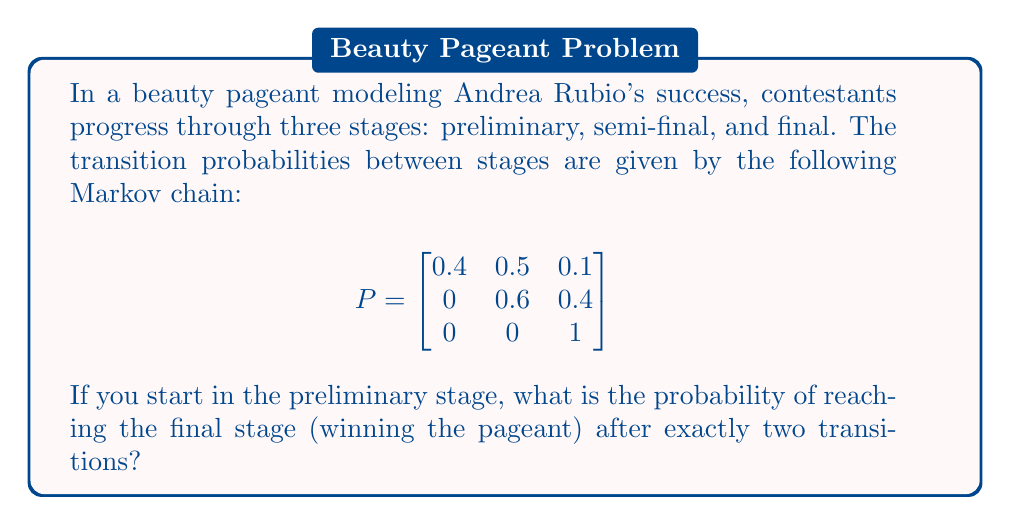Show me your answer to this math problem. To solve this problem, we'll use the Markov chain model and calculate the probability of reaching the final stage in exactly two steps:

1. First, we need to understand what the matrix P represents:
   - $P_{ij}$ is the probability of moving from state i to state j in one step
   - States: 1 = Preliminary, 2 = Semi-final, 3 = Final

2. To reach the final stage in exactly two transitions, we need to:
   - Move from Preliminary to Semi-final in the first step
   - Move from Semi-final to Final in the second step

3. Calculate the probability of moving from Preliminary to Semi-final:
   $P_{12} = 0.5$

4. Calculate the probability of moving from Semi-final to Final:
   $P_{23} = 0.4$

5. The probability of both events occurring is the product of their individual probabilities:
   $P(\text{Preliminary} \rightarrow \text{Semi-final} \rightarrow \text{Final}) = P_{12} \times P_{23}$

6. Substitute the values:
   $P(\text{Preliminary} \rightarrow \text{Semi-final} \rightarrow \text{Final}) = 0.5 \times 0.4 = 0.2$

Therefore, the probability of reaching the final stage (winning the pageant) after exactly two transitions, starting from the preliminary stage, is 0.2 or 20%.
Answer: 0.2 